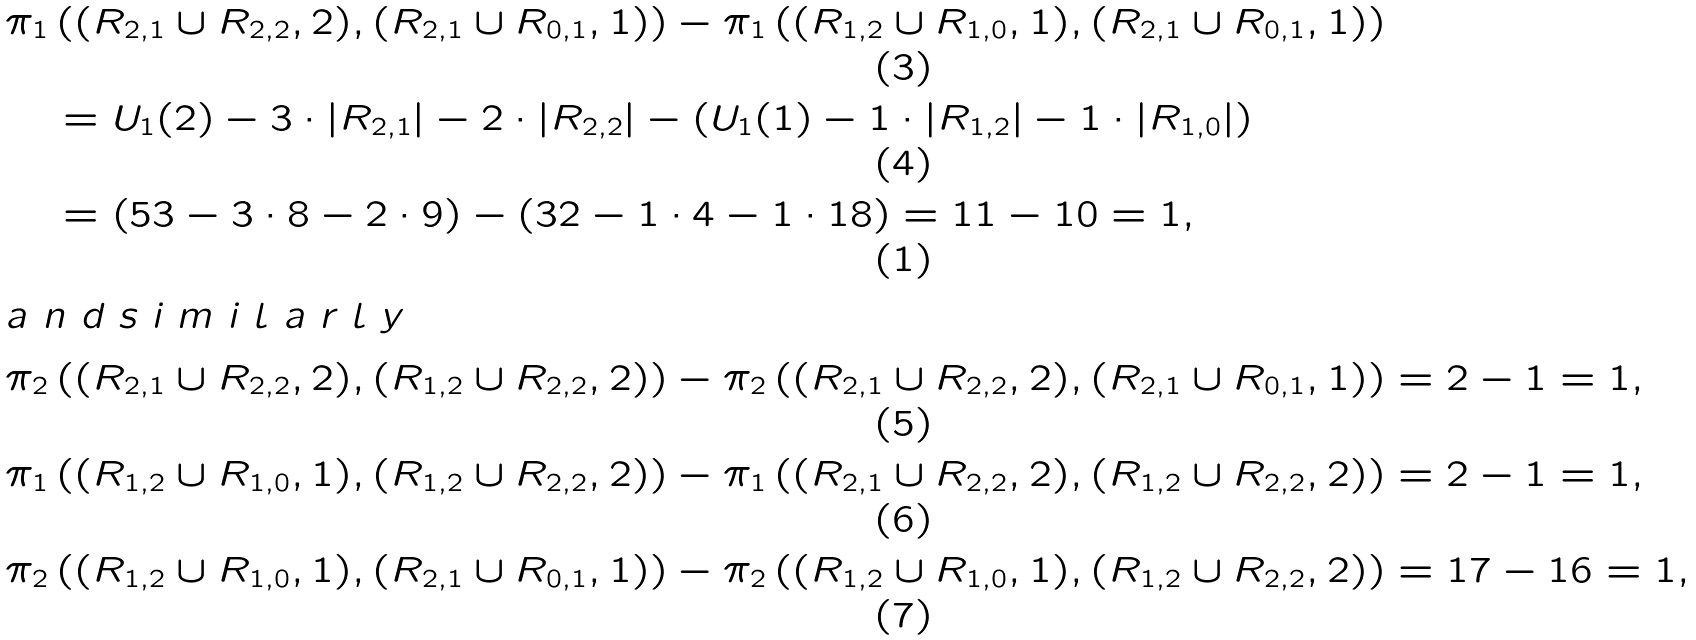<formula> <loc_0><loc_0><loc_500><loc_500>& \pi _ { 1 } \left ( ( R _ { 2 , 1 } \cup R _ { 2 , 2 } , 2 ) , ( R _ { 2 , 1 } \cup R _ { 0 , 1 } , 1 ) \right ) - \pi _ { 1 } \left ( ( R _ { 1 , 2 } \cup R _ { 1 , 0 } , 1 ) , ( R _ { 2 , 1 } \cup R _ { 0 , 1 } , 1 ) \right ) \\ & \quad = U _ { 1 } ( 2 ) - 3 \cdot | R _ { 2 , 1 } | - 2 \cdot | R _ { 2 , 2 } | - ( U _ { 1 } ( 1 ) - 1 \cdot | R _ { 1 , 2 } | - 1 \cdot | R _ { 1 , 0 } | ) \\ & \quad = \left ( 5 3 - 3 \cdot 8 - 2 \cdot 9 \right ) - \left ( 3 2 - 1 \cdot 4 - 1 \cdot 1 8 \right ) = 1 1 - 1 0 = 1 , \intertext { a n d s i m i l a r l y } & \pi _ { 2 } \left ( ( R _ { 2 , 1 } \cup R _ { 2 , 2 } , 2 ) , ( R _ { 1 , 2 } \cup R _ { 2 , 2 } , 2 ) \right ) - \pi _ { 2 } \left ( ( R _ { 2 , 1 } \cup R _ { 2 , 2 } , 2 ) , ( R _ { 2 , 1 } \cup R _ { 0 , 1 } , 1 ) \right ) = 2 - 1 = 1 , \\ & \pi _ { 1 } \left ( ( R _ { 1 , 2 } \cup R _ { 1 , 0 } , 1 ) , ( R _ { 1 , 2 } \cup R _ { 2 , 2 } , 2 ) \right ) - \pi _ { 1 } \left ( ( R _ { 2 , 1 } \cup R _ { 2 , 2 } , 2 ) , ( R _ { 1 , 2 } \cup R _ { 2 , 2 } , 2 ) \right ) = 2 - 1 = 1 , \\ & \pi _ { 2 } \left ( ( R _ { 1 , 2 } \cup R _ { 1 , 0 } , 1 ) , ( R _ { 2 , 1 } \cup R _ { 0 , 1 } , 1 ) \right ) - \pi _ { 2 } \left ( ( R _ { 1 , 2 } \cup R _ { 1 , 0 } , 1 ) , ( R _ { 1 , 2 } \cup R _ { 2 , 2 } , 2 ) \right ) = 1 7 - 1 6 = 1 ,</formula> 